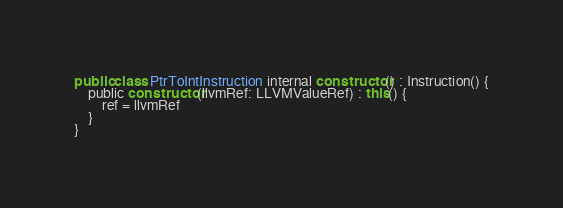<code> <loc_0><loc_0><loc_500><loc_500><_Kotlin_>
public class PtrToIntInstruction internal constructor() : Instruction() {
    public constructor(llvmRef: LLVMValueRef) : this() {
        ref = llvmRef
    }
}
</code> 